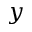<formula> <loc_0><loc_0><loc_500><loc_500>y</formula> 